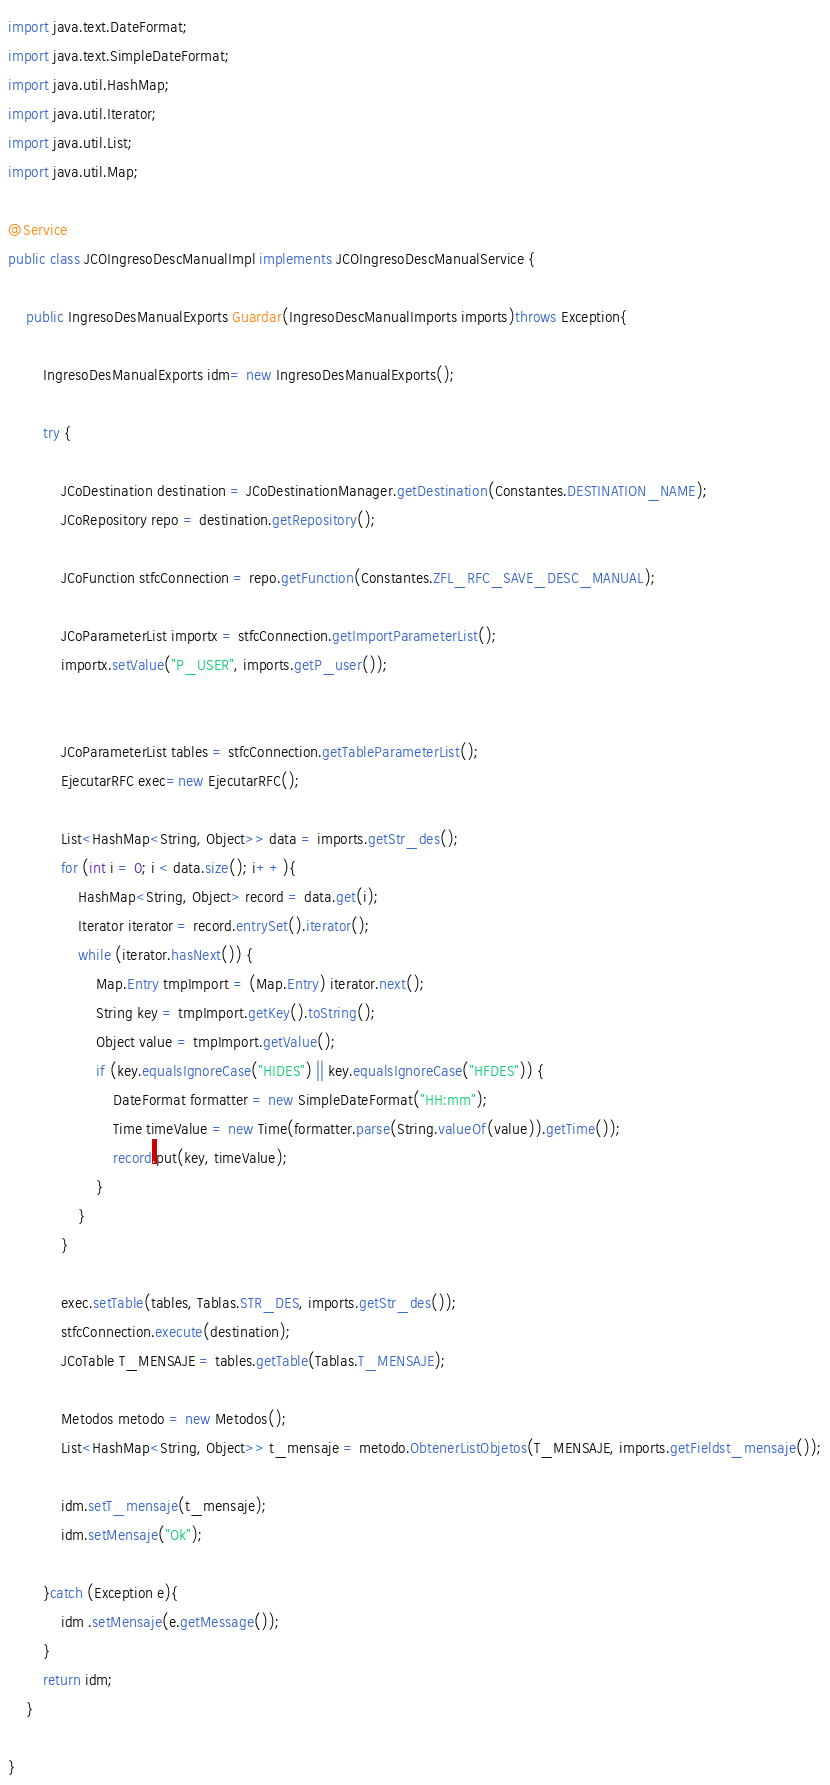<code> <loc_0><loc_0><loc_500><loc_500><_Java_>import java.text.DateFormat;
import java.text.SimpleDateFormat;
import java.util.HashMap;
import java.util.Iterator;
import java.util.List;
import java.util.Map;

@Service
public class JCOIngresoDescManualImpl implements JCOIngresoDescManualService {

    public IngresoDesManualExports Guardar(IngresoDescManualImports imports)throws Exception{

        IngresoDesManualExports idm= new IngresoDesManualExports();

        try {

            JCoDestination destination = JCoDestinationManager.getDestination(Constantes.DESTINATION_NAME);
            JCoRepository repo = destination.getRepository();

            JCoFunction stfcConnection = repo.getFunction(Constantes.ZFL_RFC_SAVE_DESC_MANUAL);

            JCoParameterList importx = stfcConnection.getImportParameterList();
            importx.setValue("P_USER", imports.getP_user());


            JCoParameterList tables = stfcConnection.getTableParameterList();
            EjecutarRFC exec=new EjecutarRFC();

            List<HashMap<String, Object>> data = imports.getStr_des();
            for (int i = 0; i < data.size(); i++){
                HashMap<String, Object> record = data.get(i);
                Iterator iterator = record.entrySet().iterator();
                while (iterator.hasNext()) {
                    Map.Entry tmpImport = (Map.Entry) iterator.next();
                    String key = tmpImport.getKey().toString();
                    Object value = tmpImport.getValue();
                    if (key.equalsIgnoreCase("HIDES") || key.equalsIgnoreCase("HFDES")) {
                        DateFormat formatter = new SimpleDateFormat("HH:mm");
                        Time timeValue = new Time(formatter.parse(String.valueOf(value)).getTime());
                        record.put(key, timeValue);
                    }
                }
            }

            exec.setTable(tables, Tablas.STR_DES, imports.getStr_des());
            stfcConnection.execute(destination);
            JCoTable T_MENSAJE = tables.getTable(Tablas.T_MENSAJE);

            Metodos metodo = new Metodos();
            List<HashMap<String, Object>> t_mensaje = metodo.ObtenerListObjetos(T_MENSAJE, imports.getFieldst_mensaje());

            idm.setT_mensaje(t_mensaje);
            idm.setMensaje("Ok");

        }catch (Exception e){
            idm .setMensaje(e.getMessage());
        }
        return idm;
    }

}</code> 